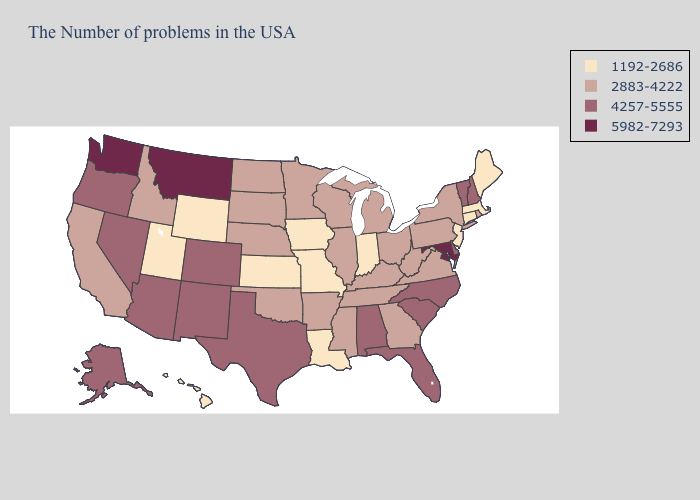Is the legend a continuous bar?
Keep it brief. No. Name the states that have a value in the range 4257-5555?
Write a very short answer. New Hampshire, Vermont, Delaware, North Carolina, South Carolina, Florida, Alabama, Texas, Colorado, New Mexico, Arizona, Nevada, Oregon, Alaska. What is the value of Connecticut?
Quick response, please. 1192-2686. What is the highest value in states that border New Mexico?
Answer briefly. 4257-5555. Name the states that have a value in the range 5982-7293?
Give a very brief answer. Maryland, Montana, Washington. Name the states that have a value in the range 1192-2686?
Short answer required. Maine, Massachusetts, Connecticut, New Jersey, Indiana, Louisiana, Missouri, Iowa, Kansas, Wyoming, Utah, Hawaii. Does the first symbol in the legend represent the smallest category?
Give a very brief answer. Yes. What is the value of Mississippi?
Write a very short answer. 2883-4222. What is the value of Utah?
Short answer required. 1192-2686. Which states have the highest value in the USA?
Write a very short answer. Maryland, Montana, Washington. Does Maryland have the highest value in the USA?
Write a very short answer. Yes. Name the states that have a value in the range 2883-4222?
Short answer required. Rhode Island, New York, Pennsylvania, Virginia, West Virginia, Ohio, Georgia, Michigan, Kentucky, Tennessee, Wisconsin, Illinois, Mississippi, Arkansas, Minnesota, Nebraska, Oklahoma, South Dakota, North Dakota, Idaho, California. Which states hav the highest value in the MidWest?
Be succinct. Ohio, Michigan, Wisconsin, Illinois, Minnesota, Nebraska, South Dakota, North Dakota. What is the value of New York?
Concise answer only. 2883-4222. Does Montana have the lowest value in the West?
Keep it brief. No. 